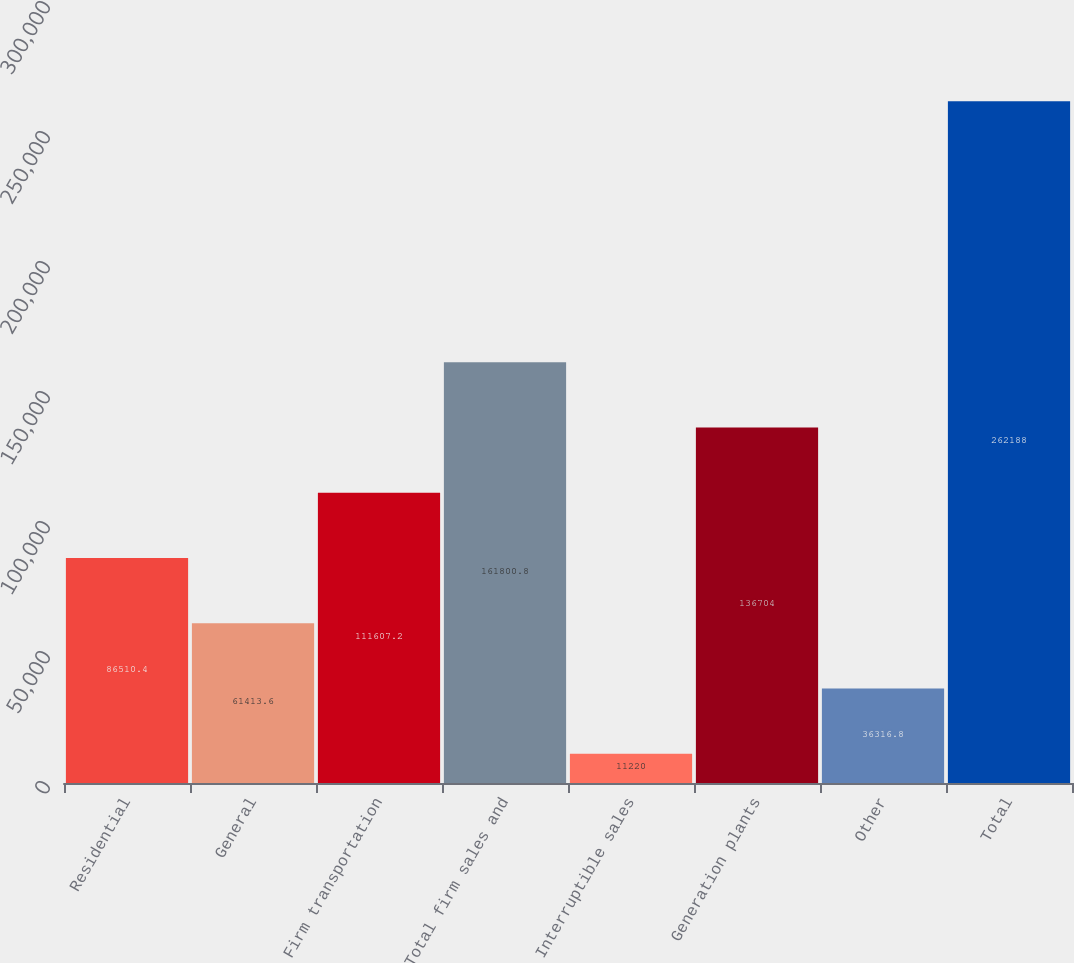Convert chart. <chart><loc_0><loc_0><loc_500><loc_500><bar_chart><fcel>Residential<fcel>General<fcel>Firm transportation<fcel>Total firm sales and<fcel>Interruptible sales<fcel>Generation plants<fcel>Other<fcel>Total<nl><fcel>86510.4<fcel>61413.6<fcel>111607<fcel>161801<fcel>11220<fcel>136704<fcel>36316.8<fcel>262188<nl></chart> 